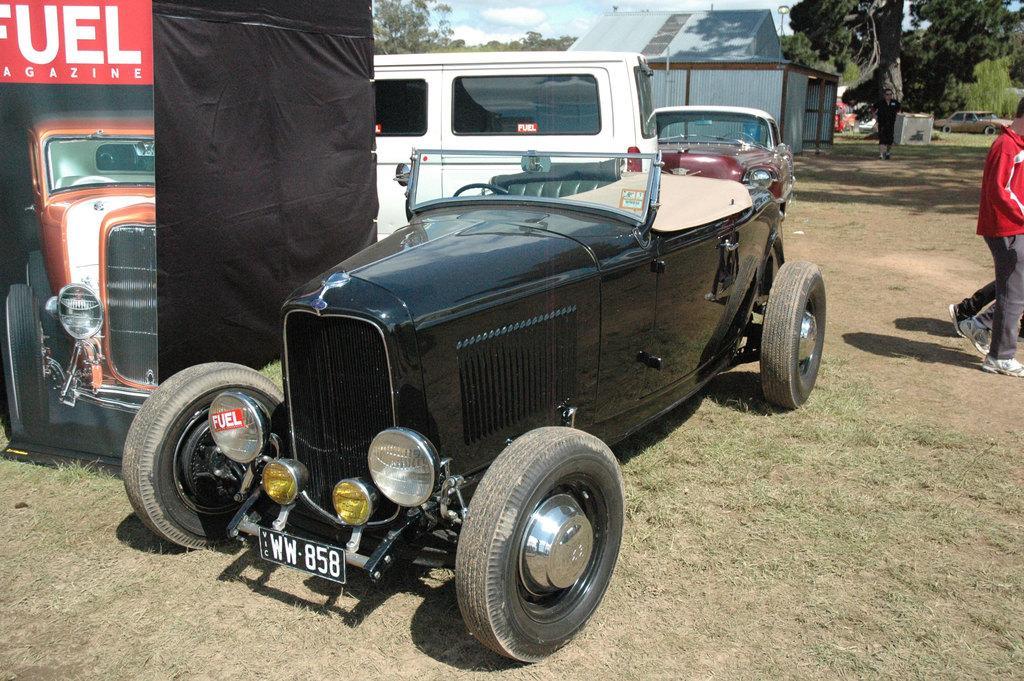Can you describe this image briefly? In the picture I can see vehicles and people on the ground. I can also see a house, trees, the grass and some other objects on the ground. In the background I can see the sky. 